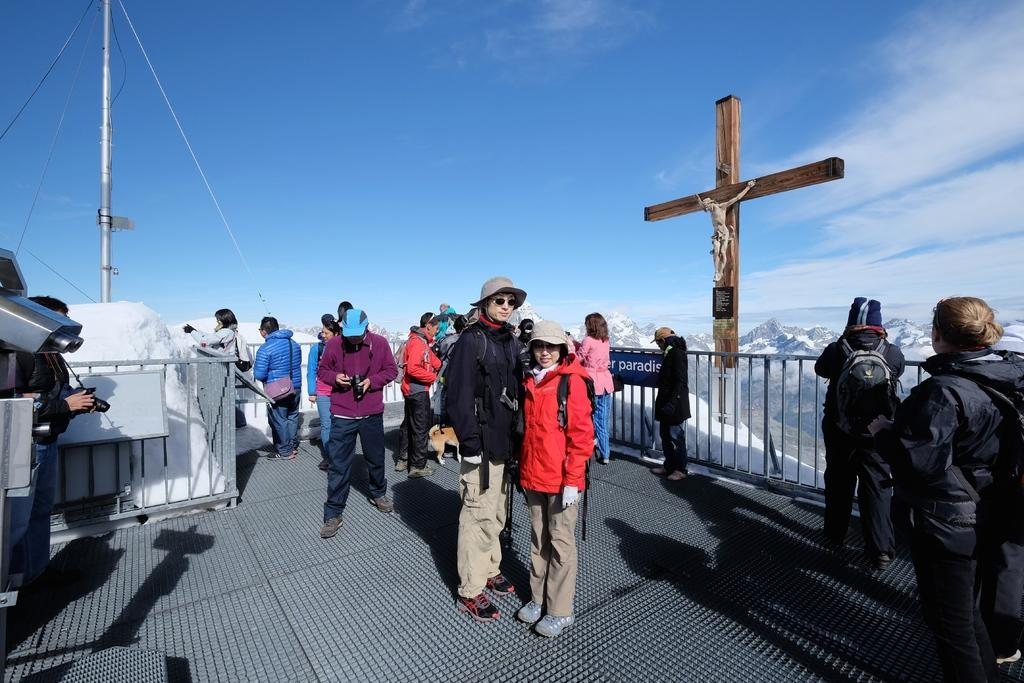How many people are present in the image? There are many people in the image. What is the main subject in the middle of the image? There is a statue of Jesus Christ in the middle of the image. What can be seen at the top of the image? Sky is visible at the top of the image. What are some people doing in the image? Some people are clicking pictures in the image. How many brothers are standing next to the statue in the image? There is no mention of brothers in the image, nor is there any indication of their presence. Who is the friend of the person taking a picture in the image? There is no information about friends or relationships between people in the image. 